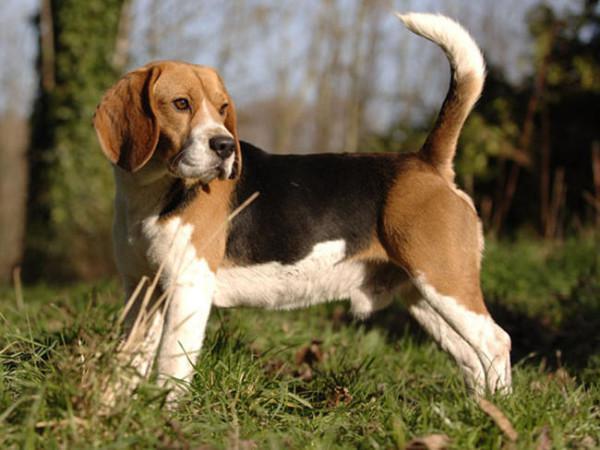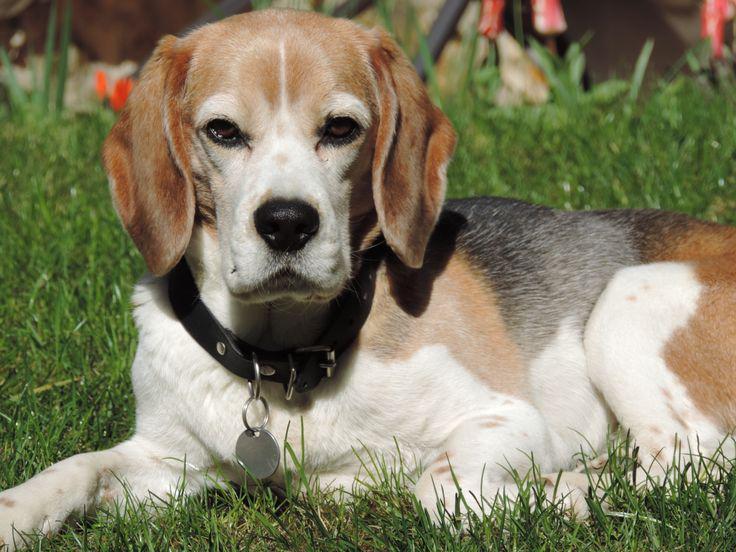The first image is the image on the left, the second image is the image on the right. Analyze the images presented: Is the assertion "All the dogs are lying down." valid? Answer yes or no. No. 